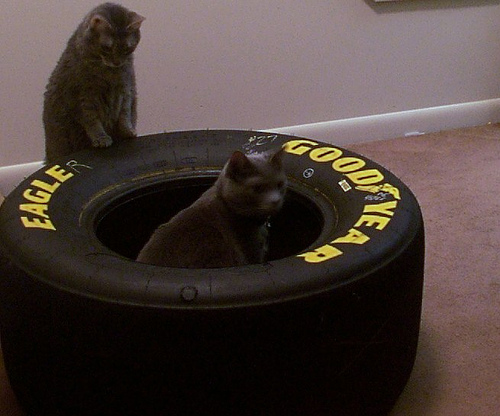<image>
Can you confirm if the cat is next to the cat? Yes. The cat is positioned adjacent to the cat, located nearby in the same general area. 